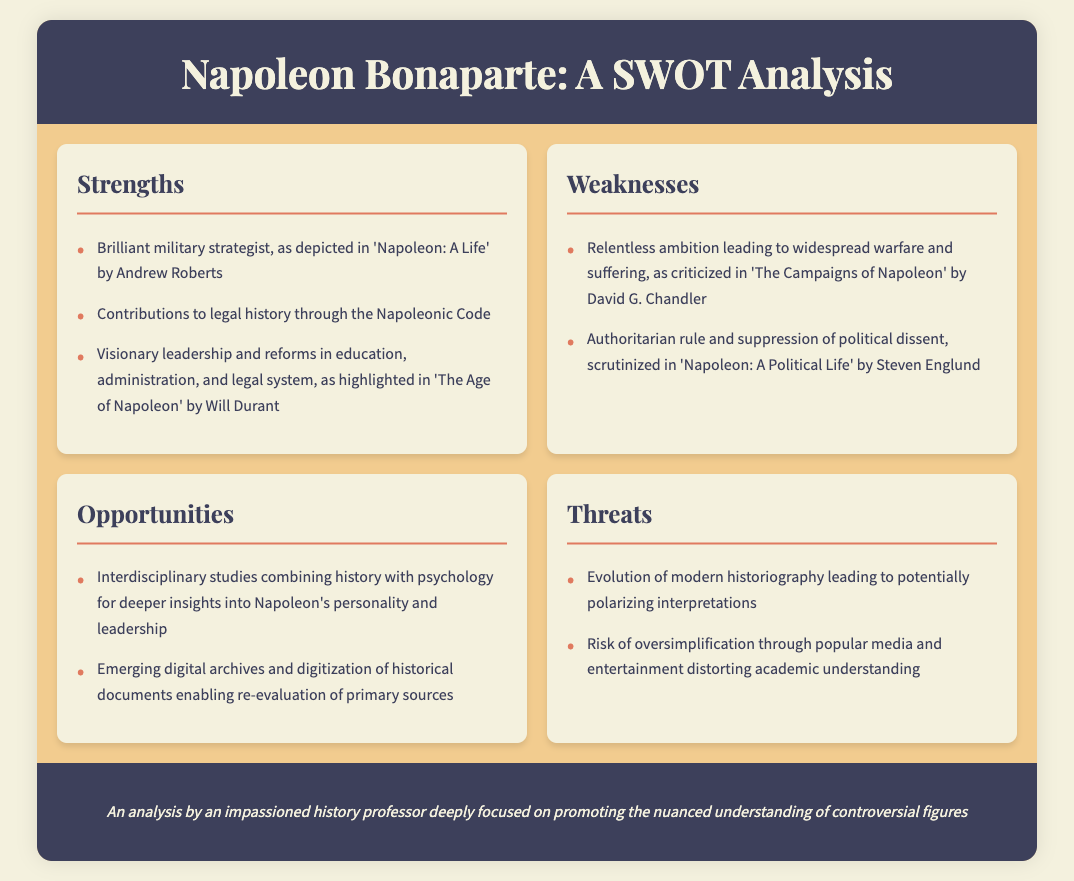What are the strengths of Napoleon Bonaparte? The strengths mentioned include his strategic genius, legal contributions, and visionary leadership in reforms.
Answer: Brilliant military strategist, contributions to legal history, visionary leadership and reforms What is one of the weaknesses attributed to Napoleon? The weaknesses highlighted include his relentless ambition and authoritarian rule.
Answer: Relentless ambition What opportunity is mentioned in relation to the study of Napoleon Bonaparte? The document indicates that interdisciplinary studies combining history and psychology can provide deeper insights.
Answer: Interdisciplinary studies How many threats are listed in the document? There are two threats described, concerning historiography and media distortion.
Answer: Two Which author wrote "The Campaigns of Napoleon"? David G. Chandler is the author mentioned in the document.
Answer: David G. Chandler What is the name of the legal code associated with Napoleon? The Napoleonic Code is noted as a significant contribution in the document.
Answer: Napoleonic Code Which historical text highlights Napoleon's reforms in education and administration? "The Age of Napoleon" by Will Durant discusses these reforms in detail.
Answer: The Age of Napoleon What is a potential risk related to popular media as per the document? The document warns against the risk of oversimplification due to popular media and entertainment.
Answer: Oversimplification through popular media 